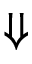Convert formula to latex. <formula><loc_0><loc_0><loc_500><loc_500>\Downarrow</formula> 